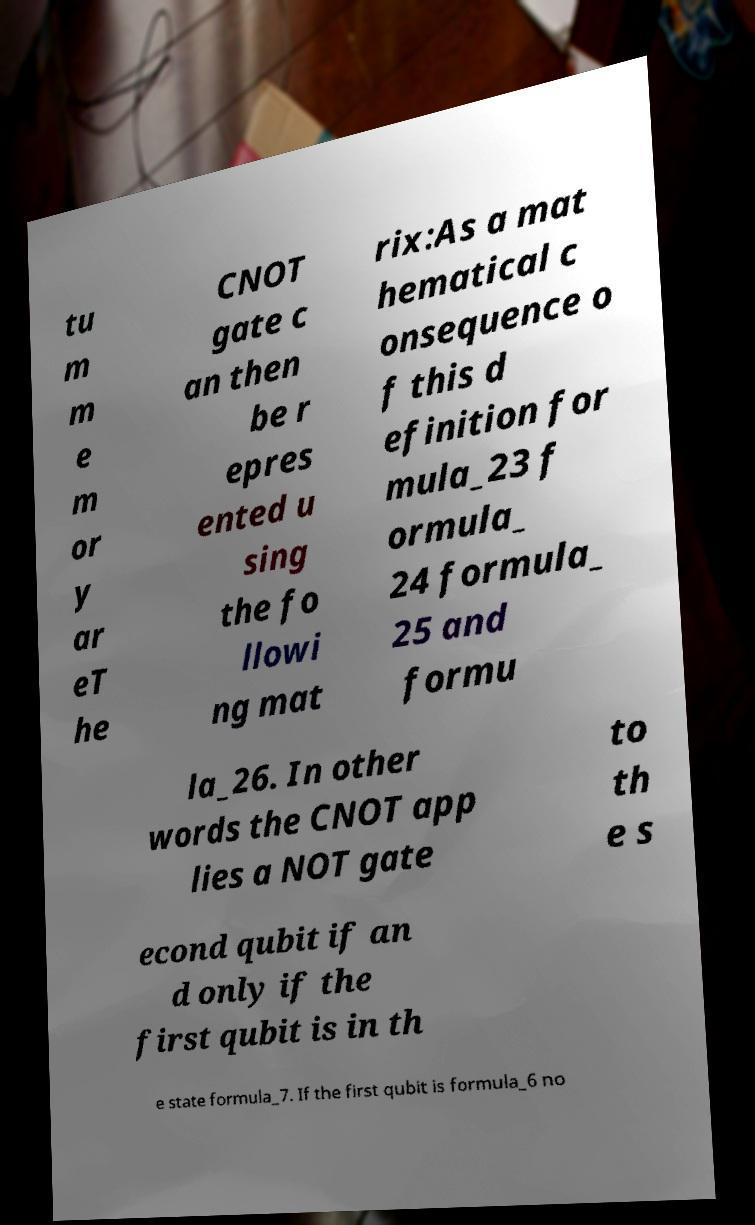I need the written content from this picture converted into text. Can you do that? tu m m e m or y ar eT he CNOT gate c an then be r epres ented u sing the fo llowi ng mat rix:As a mat hematical c onsequence o f this d efinition for mula_23 f ormula_ 24 formula_ 25 and formu la_26. In other words the CNOT app lies a NOT gate to th e s econd qubit if an d only if the first qubit is in th e state formula_7. If the first qubit is formula_6 no 